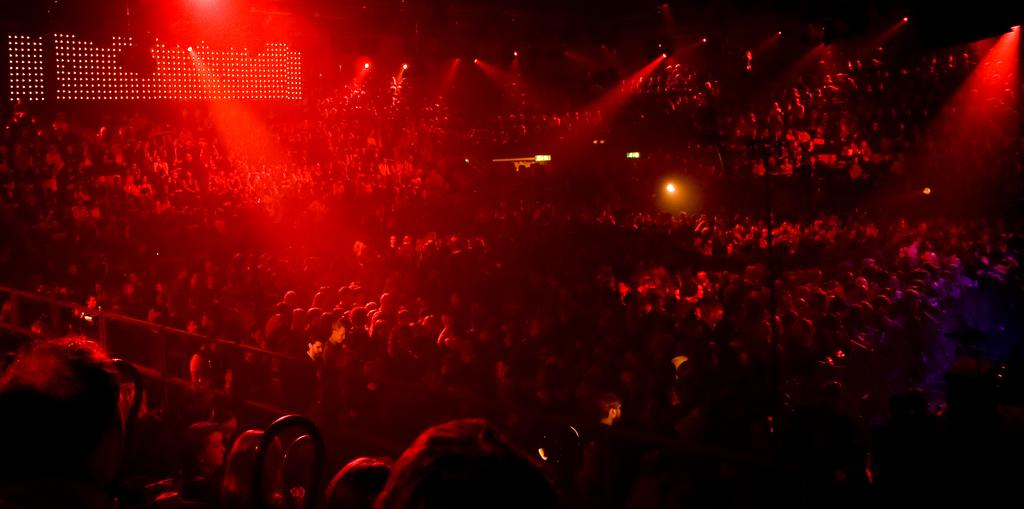What is the main subject of the image? The main subject of the image is a group of people. Can you describe the people in the image? There are many people in the middle of the image. What else can be seen in the image besides the people? There are focus lights visible at the top of the image. What type of drink is being traded between the zebras in the image? There are no zebras present in the image, and therefore no such activity can be observed. 